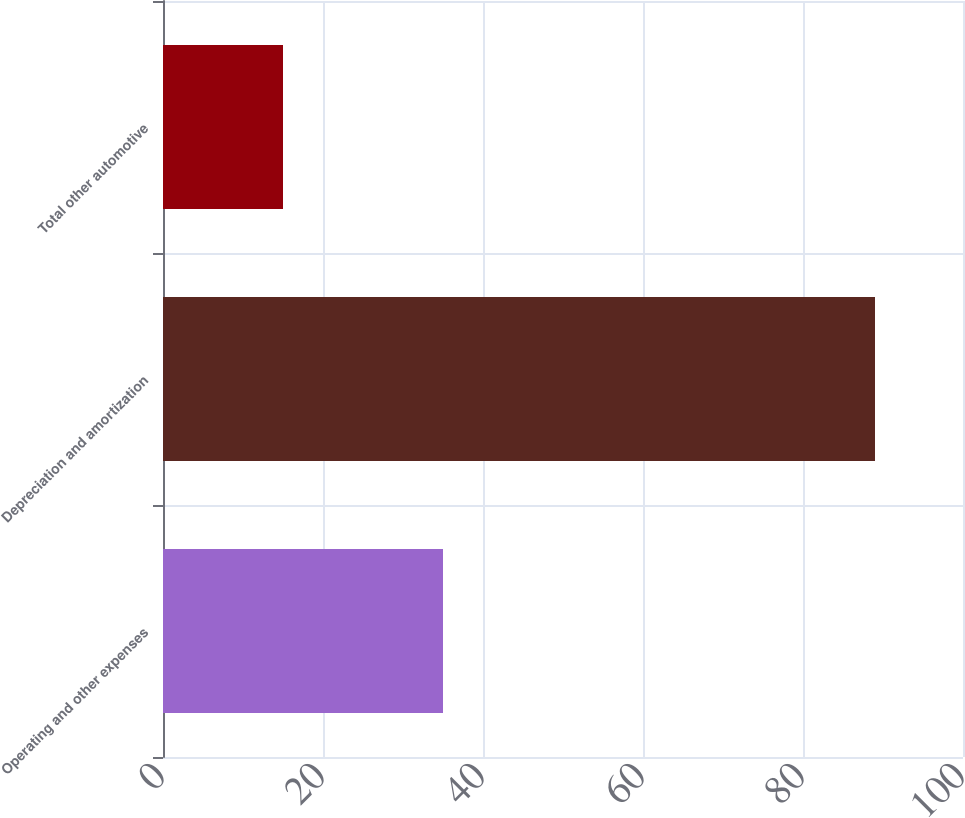Convert chart. <chart><loc_0><loc_0><loc_500><loc_500><bar_chart><fcel>Operating and other expenses<fcel>Depreciation and amortization<fcel>Total other automotive<nl><fcel>35<fcel>89<fcel>15<nl></chart> 